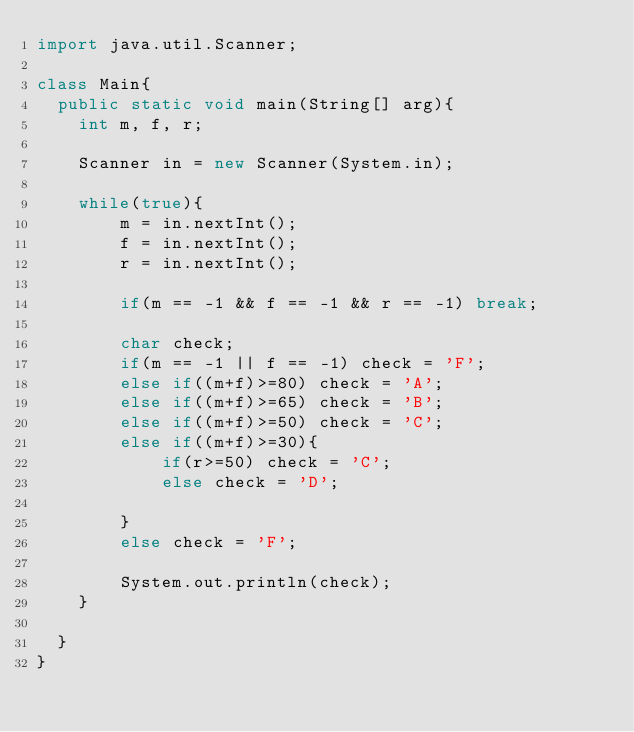Convert code to text. <code><loc_0><loc_0><loc_500><loc_500><_Java_>import java.util.Scanner;
 
class Main{
  public static void main(String[] arg){
    int m, f, r;

    Scanner in = new Scanner(System.in);

    while(true){
        m = in.nextInt();
        f = in.nextInt();
        r = in.nextInt();
        
        if(m == -1 && f == -1 && r == -1) break;

        char check;
        if(m == -1 || f == -1) check = 'F';
        else if((m+f)>=80) check = 'A';
        else if((m+f)>=65) check = 'B';
        else if((m+f)>=50) check = 'C';
        else if((m+f)>=30){
            if(r>=50) check = 'C';
            else check = 'D';

        }
        else check = 'F';

        System.out.println(check);
    }

  }
}</code> 